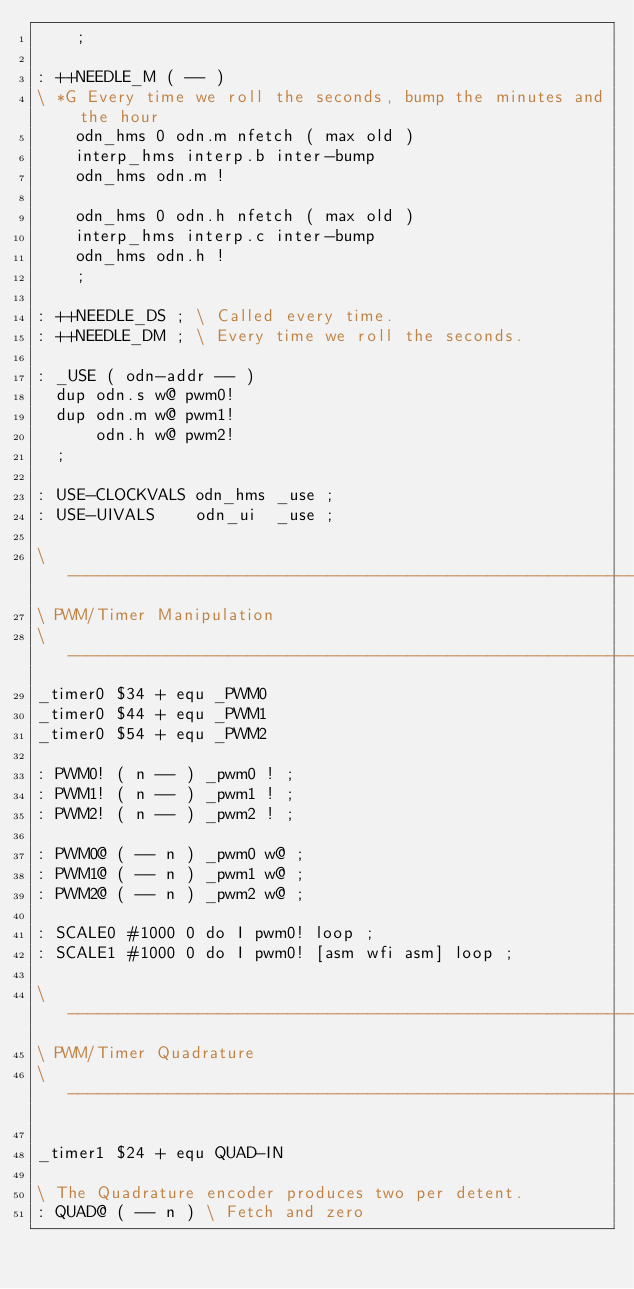<code> <loc_0><loc_0><loc_500><loc_500><_Forth_>	;

: ++NEEDLE_M ( -- )
\ *G Every time we roll the seconds, bump the minutes and the hour
	odn_hms 0 odn.m nfetch ( max old )
	interp_hms interp.b inter-bump 
	odn_hms odn.m ! 

	odn_hms 0 odn.h nfetch ( max old )
	interp_hms interp.c inter-bump 
	odn_hms odn.h ! 
	;

: ++NEEDLE_DS ; \ Called every time.
: ++NEEDLE_DM ; \ Every time we roll the seconds.

: _USE ( odn-addr -- ) 
  dup odn.s w@ pwm0!
  dup odn.m w@ pwm1!
      odn.h w@ pwm2!
  ;

: USE-CLOCKVALS odn_hms _use ; 
: USE-UIVALS    odn_ui  _use ; 

\ ----------------------------------------------------------
\ PWM/Timer Manipulation
\ ----------------------------------------------------------
_timer0 $34 + equ _PWM0 
_timer0 $44 + equ _PWM1 
_timer0 $54 + equ _PWM2 

: PWM0! ( n -- ) _pwm0 ! ;
: PWM1! ( n -- ) _pwm1 ! ;
: PWM2! ( n -- ) _pwm2 ! ;

: PWM0@ ( -- n ) _pwm0 w@ ;
: PWM1@ ( -- n ) _pwm1 w@ ;
: PWM2@ ( -- n ) _pwm2 w@ ;

: SCALE0 #1000 0 do I pwm0! loop ; 
: SCALE1 #1000 0 do I pwm0! [asm wfi asm] loop ; 

\ ----------------------------------------------------------
\ PWM/Timer Quadrature
\ ----------------------------------------------------------

_timer1 $24 + equ QUAD-IN

\ The Quadrature encoder produces two per detent.
: QUAD@ ( -- n ) \ Fetch and zero</code> 